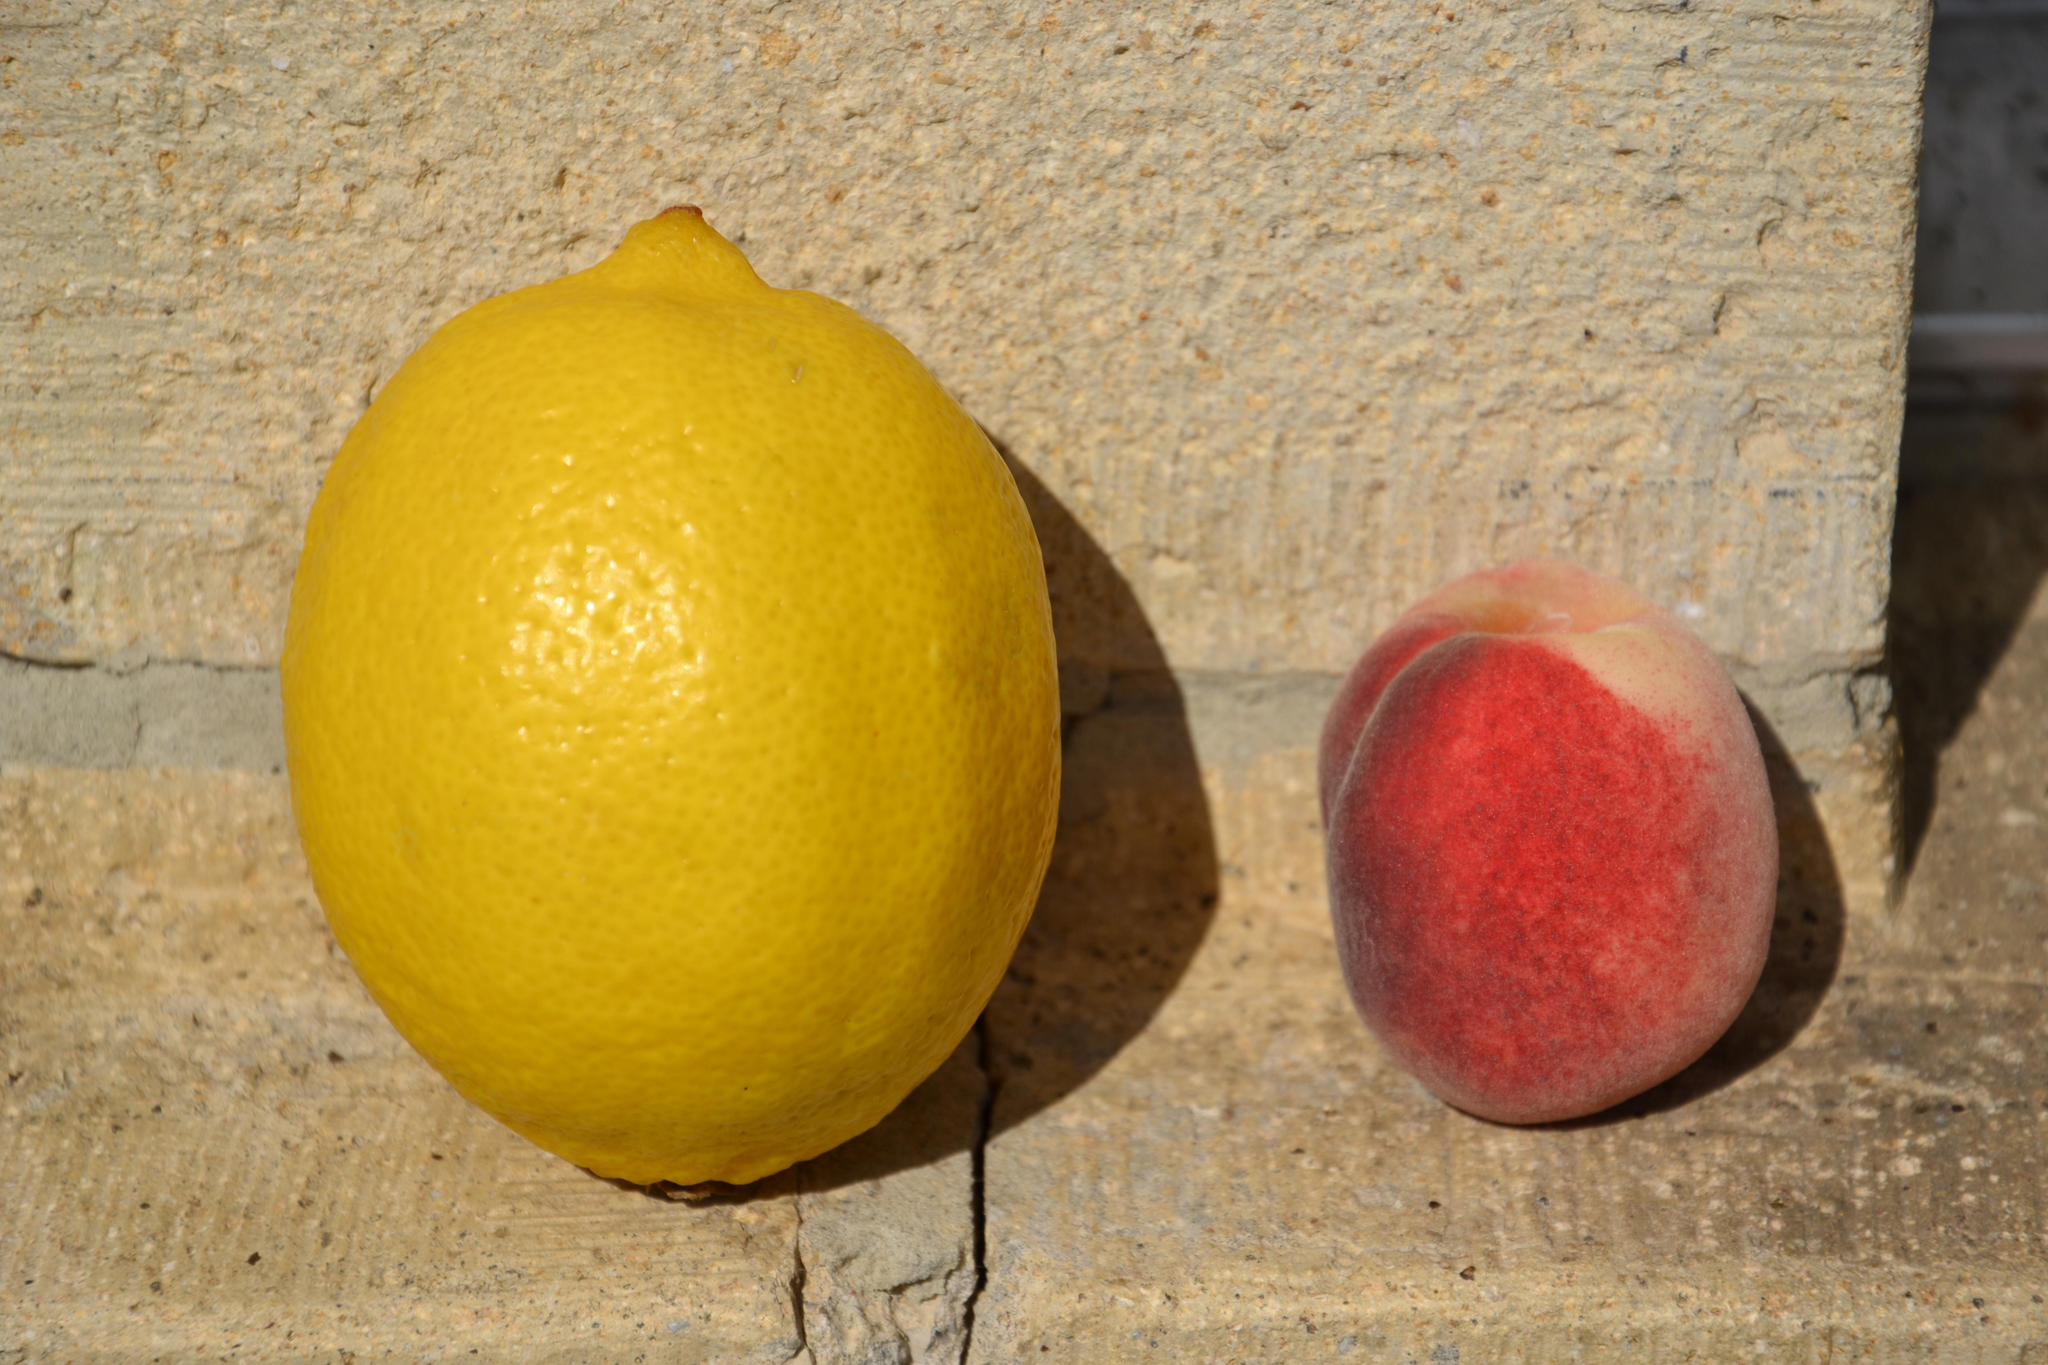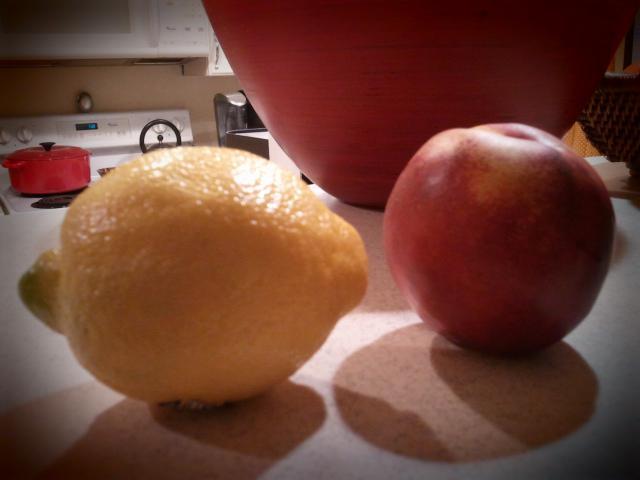The first image is the image on the left, the second image is the image on the right. For the images displayed, is the sentence "The right image contains two sliced lemons hanging from the lid of two glass smoothie cups." factually correct? Answer yes or no. No. 